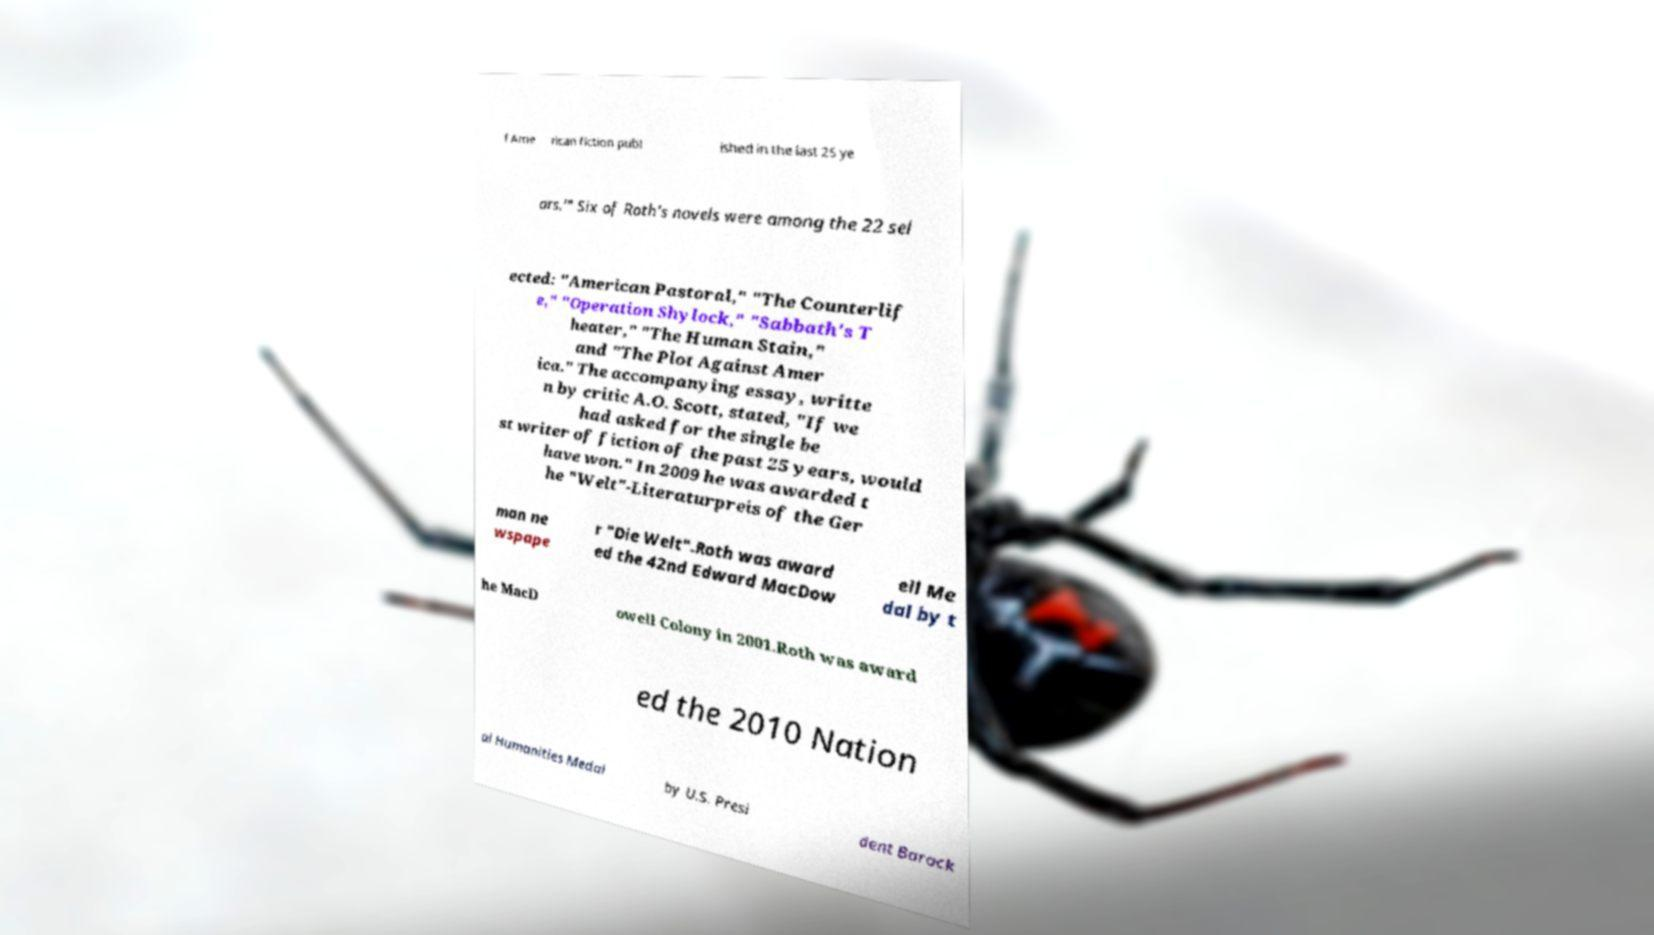There's text embedded in this image that I need extracted. Can you transcribe it verbatim? f Ame rican fiction publ ished in the last 25 ye ars.'" Six of Roth's novels were among the 22 sel ected: "American Pastoral," "The Counterlif e," "Operation Shylock," "Sabbath's T heater," "The Human Stain," and "The Plot Against Amer ica." The accompanying essay, writte n by critic A.O. Scott, stated, "If we had asked for the single be st writer of fiction of the past 25 years, would have won." In 2009 he was awarded t he "Welt"-Literaturpreis of the Ger man ne wspape r "Die Welt".Roth was award ed the 42nd Edward MacDow ell Me dal by t he MacD owell Colony in 2001.Roth was award ed the 2010 Nation al Humanities Medal by U.S. Presi dent Barack 